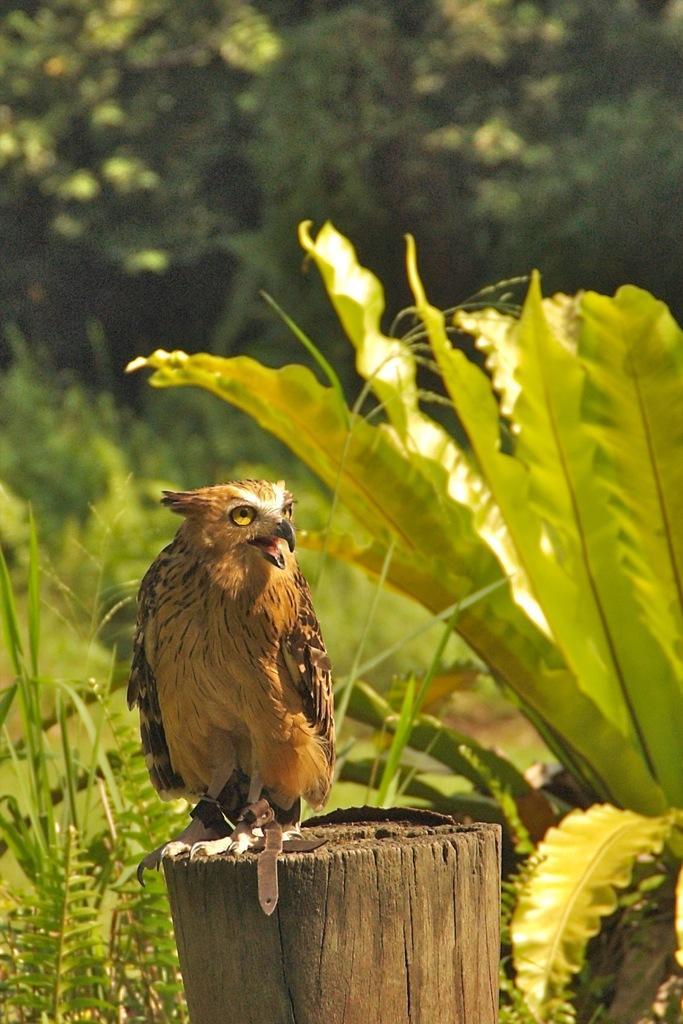How would you summarize this image in a sentence or two? In this image there is a bird on the wooden trunk. Behind there are plants. Background there are trees. 